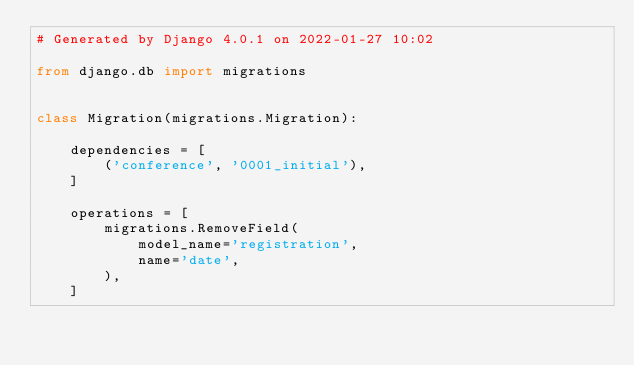Convert code to text. <code><loc_0><loc_0><loc_500><loc_500><_Python_># Generated by Django 4.0.1 on 2022-01-27 10:02

from django.db import migrations


class Migration(migrations.Migration):

    dependencies = [
        ('conference', '0001_initial'),
    ]

    operations = [
        migrations.RemoveField(
            model_name='registration',
            name='date',
        ),
    ]
</code> 